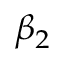<formula> <loc_0><loc_0><loc_500><loc_500>\beta _ { 2 }</formula> 